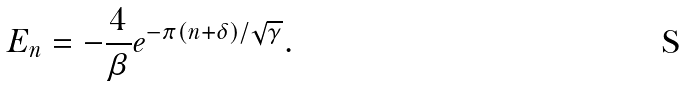Convert formula to latex. <formula><loc_0><loc_0><loc_500><loc_500>E _ { n } = - \frac { 4 } { \beta } e ^ { - \pi ( n + \delta ) / \sqrt { \gamma } } .</formula> 